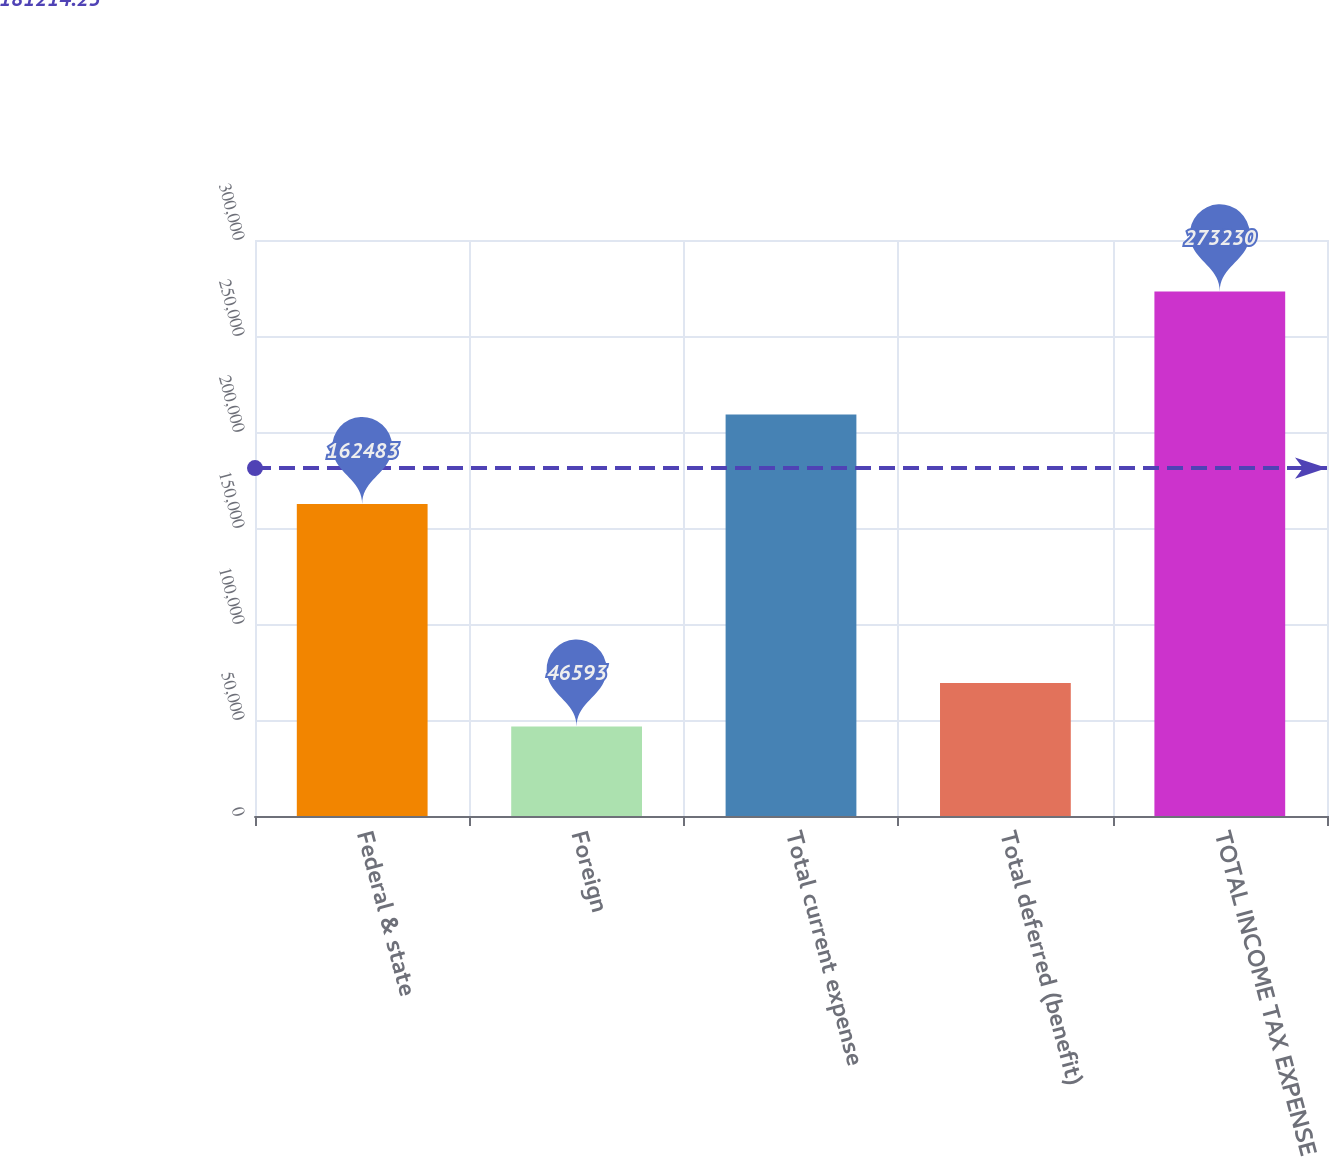Convert chart to OTSL. <chart><loc_0><loc_0><loc_500><loc_500><bar_chart><fcel>Federal & state<fcel>Foreign<fcel>Total current expense<fcel>Total deferred (benefit)<fcel>TOTAL INCOME TAX EXPENSE<nl><fcel>162483<fcel>46593<fcel>209076<fcel>69256.7<fcel>273230<nl></chart> 